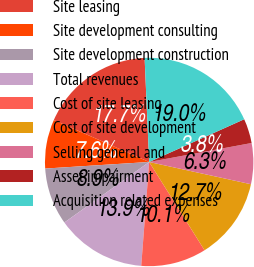<chart> <loc_0><loc_0><loc_500><loc_500><pie_chart><fcel>Site leasing<fcel>Site development consulting<fcel>Site development construction<fcel>Total revenues<fcel>Cost of site leasing<fcel>Cost of site development<fcel>Selling general and<fcel>Asset impairment<fcel>Acquisition related expenses<nl><fcel>17.71%<fcel>7.6%<fcel>8.86%<fcel>13.92%<fcel>10.13%<fcel>12.66%<fcel>6.34%<fcel>3.81%<fcel>18.97%<nl></chart> 